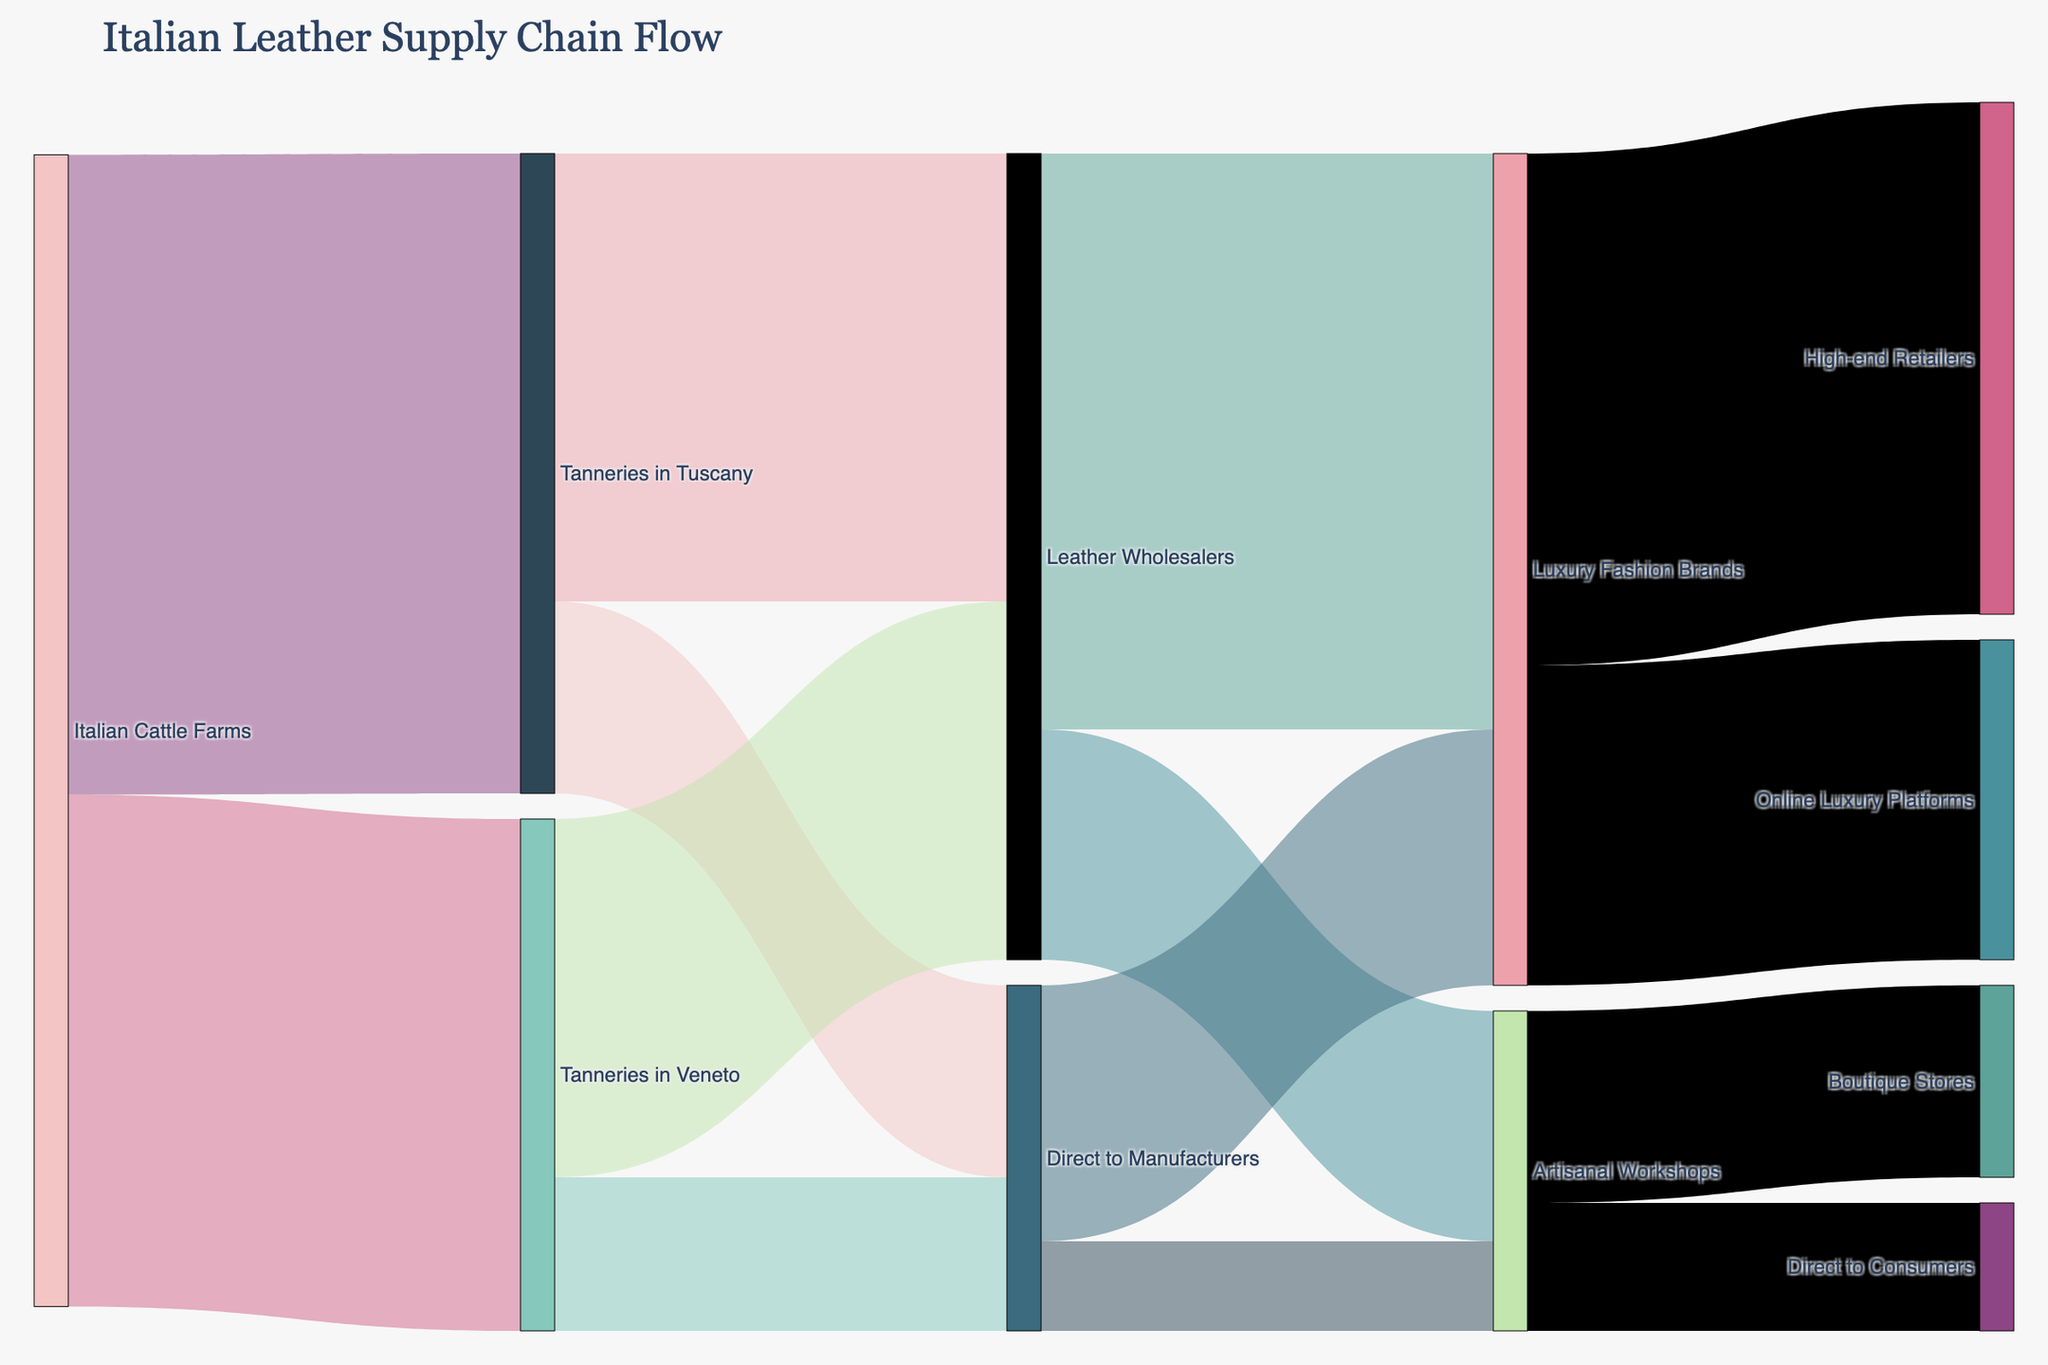What is the title of the diagram? The title of the diagram is displayed at the top and reads "Italian Leather Supply Chain Flow".
Answer: Italian Leather Supply Chain Flow Where does most of the leather from Tanneries in Tuscany go? By tracing the thicker flows from Tanneries in Tuscany, it can be seen that most leather goes to Leather Wholesalers, represented by a flow value of 3500.
Answer: Leather Wholesalers How much leather is supplied directly from Italian Cattle Farms to Tanneries in Veneto? The link from Italian Cattle Farms to Tanneries in Veneto shows the value as 4000, which is directly traceable to the corresponding flow.
Answer: 4000 Compare the amount of leather that goes from Tanneries in Veneto to Leather Wholesalers versus Direct to Manufacturers. Which is greater and by how much? From the diagram, Tanneries in Veneto sends 2800 to Leather Wholesalers and 1200 to Direct to Manufacturers. The difference in values is 2800 - 1200 = 1600, showing that more leather goes to Leather Wholesalers by 1600 units.
Answer: Leather Wholesalers, by 1600 units How much leather is supplied to Luxury Fashion Brands from both the direct sources combined? Leather coming from Direct to Manufacturers to Luxury Fashion Brands is 2000. The amount from Leather Wholesalers to Luxury Fashion Brands is 4500. The combined value is 2000 + 4500 = 6500.
Answer: 6500 Which has more leather flow: Artisanal Workshops to Boutique Stores or Direct to Consumers? The Sankey diagram shows flows of 1500 from Artisanal Workshops to Boutique Stores and 1000 from Artisanal Workshops to Direct to Consumers. Thus, more leather flows to Boutique Stores.
Answer: Boutique Stores How much leather flows directly to Online Luxury Platforms as opposed to High-end Retailers? Leather from Luxury Fashion Brands goes to Online Luxury Platforms by a value of 2500 and to High-end Retailers by a value of 4000. Therefore, the direct flow to High-end Retailers is greater.
Answer: High-end Retailers What is the total amount of leather that ends up at Artisanal Workshops? Examining the flows, Tanneries in Tuscany send 1500 in direct and Tanneries in Veneto send 1200 directly to Artisanal Workshops, totaling 1500 + 1200 = 2700 units.
Answer: 2700 Identify which part of the supply chain has the highest single flow value and specify the amount. The highest single flow value is from Leather Wholesalers to Luxury Fashion Brands, which is visible as 4500 units in the Sankey diagram.
Answer: 4500 units 